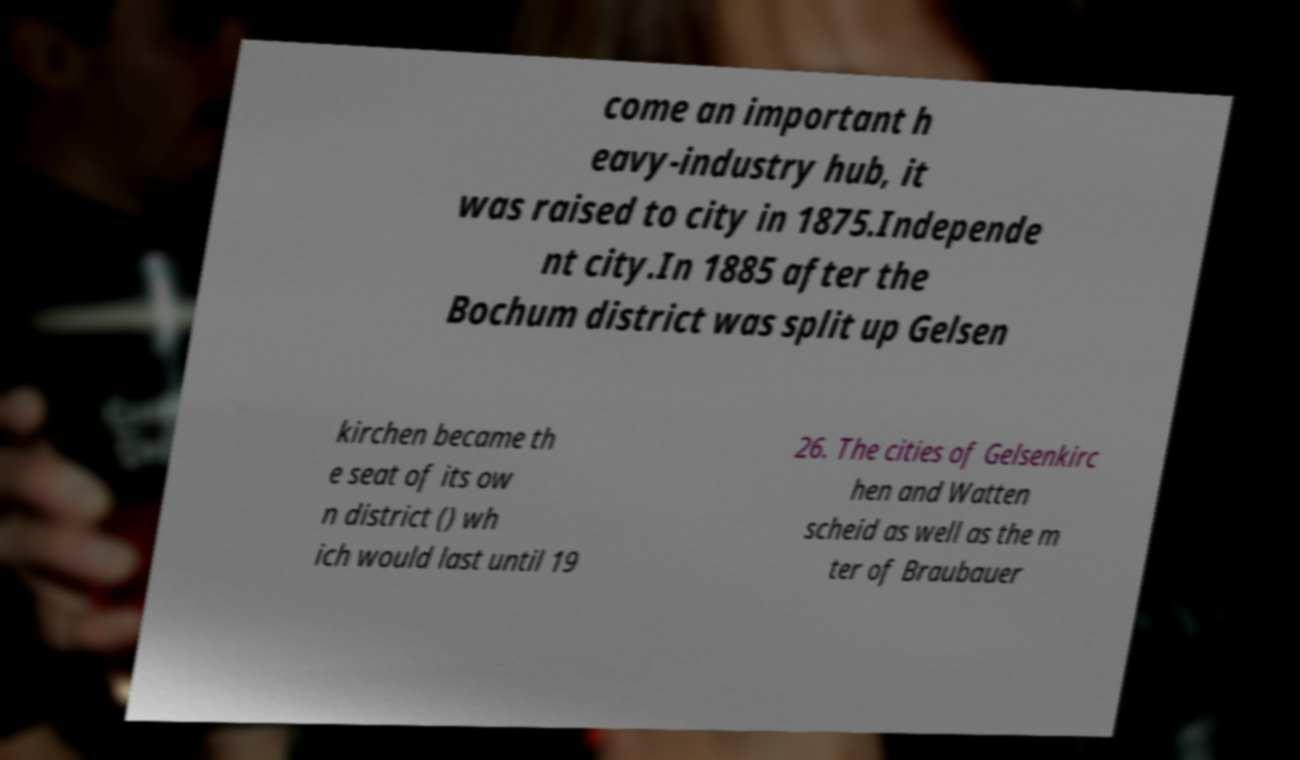There's text embedded in this image that I need extracted. Can you transcribe it verbatim? come an important h eavy-industry hub, it was raised to city in 1875.Independe nt city.In 1885 after the Bochum district was split up Gelsen kirchen became th e seat of its ow n district () wh ich would last until 19 26. The cities of Gelsenkirc hen and Watten scheid as well as the m ter of Braubauer 